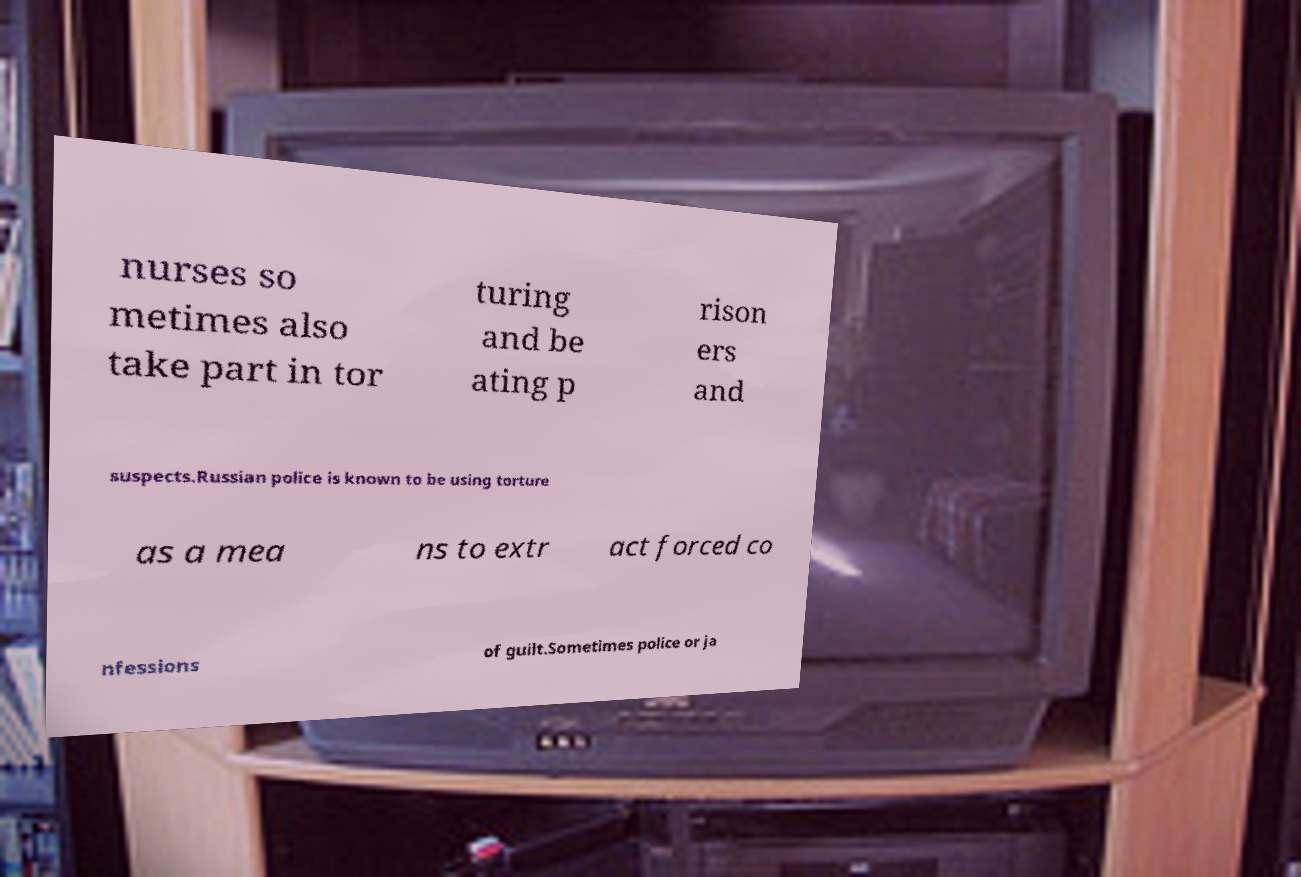I need the written content from this picture converted into text. Can you do that? nurses so metimes also take part in tor turing and be ating p rison ers and suspects.Russian police is known to be using torture as a mea ns to extr act forced co nfessions of guilt.Sometimes police or ja 